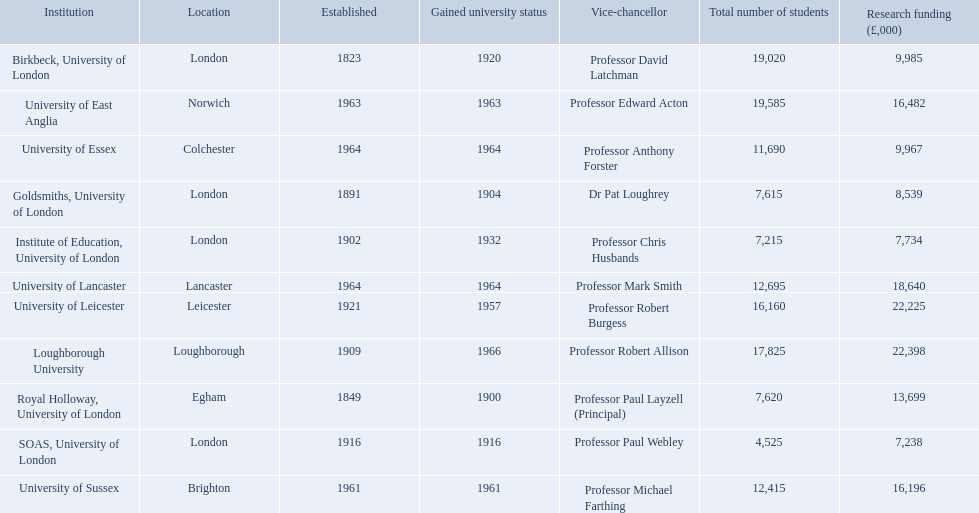Where is birbeck,university of london located? London. Which university was established in 1921? University of Leicester. Which institution gained university status recently? Loughborough University. What are the titles of all the organizations? Birkbeck, University of London, University of East Anglia, University of Essex, Goldsmiths, University of London, Institute of Education, University of London, University of Lancaster, University of Leicester, Loughborough University, Royal Holloway, University of London, SOAS, University of London, University of Sussex. In what range of years were these organizations set up? 1823, 1963, 1964, 1891, 1902, 1964, 1921, 1909, 1849, 1916, 1961. In what range of years did these organizations achieve university status? 1920, 1963, 1964, 1904, 1932, 1964, 1957, 1966, 1900, 1916, 1961. What organization most newly received university status? Loughborough University. Can you parse all the data within this table? {'header': ['Institution', 'Location', 'Established', 'Gained university status', 'Vice-chancellor', 'Total number of students', 'Research funding (£,000)'], 'rows': [['Birkbeck, University of London', 'London', '1823', '1920', 'Professor David Latchman', '19,020', '9,985'], ['University of East Anglia', 'Norwich', '1963', '1963', 'Professor Edward Acton', '19,585', '16,482'], ['University of Essex', 'Colchester', '1964', '1964', 'Professor Anthony Forster', '11,690', '9,967'], ['Goldsmiths, University of London', 'London', '1891', '1904', 'Dr Pat Loughrey', '7,615', '8,539'], ['Institute of Education, University of London', 'London', '1902', '1932', 'Professor Chris Husbands', '7,215', '7,734'], ['University of Lancaster', 'Lancaster', '1964', '1964', 'Professor Mark Smith', '12,695', '18,640'], ['University of Leicester', 'Leicester', '1921', '1957', 'Professor Robert Burgess', '16,160', '22,225'], ['Loughborough University', 'Loughborough', '1909', '1966', 'Professor Robert Allison', '17,825', '22,398'], ['Royal Holloway, University of London', 'Egham', '1849', '1900', 'Professor Paul Layzell (Principal)', '7,620', '13,699'], ['SOAS, University of London', 'London', '1916', '1916', 'Professor Paul Webley', '4,525', '7,238'], ['University of Sussex', 'Brighton', '1961', '1961', 'Professor Michael Farthing', '12,415', '16,196']]} Where can one find birkbeck, university of london? London. Which educational establishment was founded in 1921? University of Leicester. Which organization recently acquired university recognition? Loughborough University. What are the titles of all the organizations? Birkbeck, University of London, University of East Anglia, University of Essex, Goldsmiths, University of London, Institute of Education, University of London, University of Lancaster, University of Leicester, Loughborough University, Royal Holloway, University of London, SOAS, University of London, University of Sussex. During which years were these organizations founded? 1823, 1963, 1964, 1891, 1902, 1964, 1921, 1909, 1849, 1916, 1961. In which time period did these organizations acquire university status? 1920, 1963, 1964, 1904, 1932, 1964, 1957, 1966, 1900, 1916, 1961. Which organization was the most recent to achieve university status? Loughborough University. Can you provide the names of all the institutions? Birkbeck, University of London, University of East Anglia, University of Essex, Goldsmiths, University of London, Institute of Education, University of London, University of Lancaster, University of Leicester, Loughborough University, Royal Holloway, University of London, SOAS, University of London, University of Sussex. In what span of years were these institutions set up? 1823, 1963, 1964, 1891, 1902, 1964, 1921, 1909, 1849, 1916, 1961. During which years did they become universities? 1920, 1963, 1964, 1904, 1932, 1964, 1957, 1966, 1900, 1916, 1961. Which institution most recently became a university? Loughborough University. At what location is birkbeck, university of london situated? London. Which university has its roots in 1921? University of Leicester. Which institution has newly acquired university status? Loughborough University. 